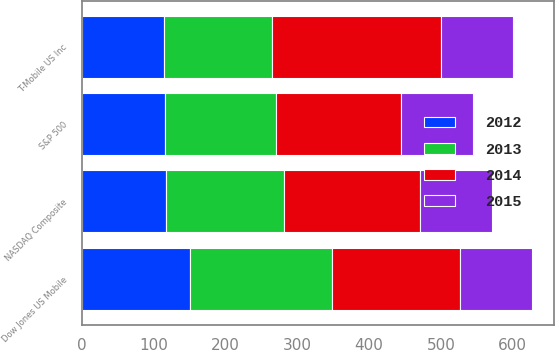Convert chart to OTSL. <chart><loc_0><loc_0><loc_500><loc_500><stacked_bar_chart><ecel><fcel>T-Mobile US Inc<fcel>S&P 500<fcel>NASDAQ Composite<fcel>Dow Jones US Mobile<nl><fcel>2015<fcel>100<fcel>100<fcel>100<fcel>100<nl><fcel>2012<fcel>114.52<fcel>116<fcel>116.41<fcel>150.31<nl><fcel>2013<fcel>150.31<fcel>153.58<fcel>165.47<fcel>198.58<nl><fcel>2014<fcel>235.83<fcel>174.6<fcel>188.69<fcel>177.4<nl></chart> 